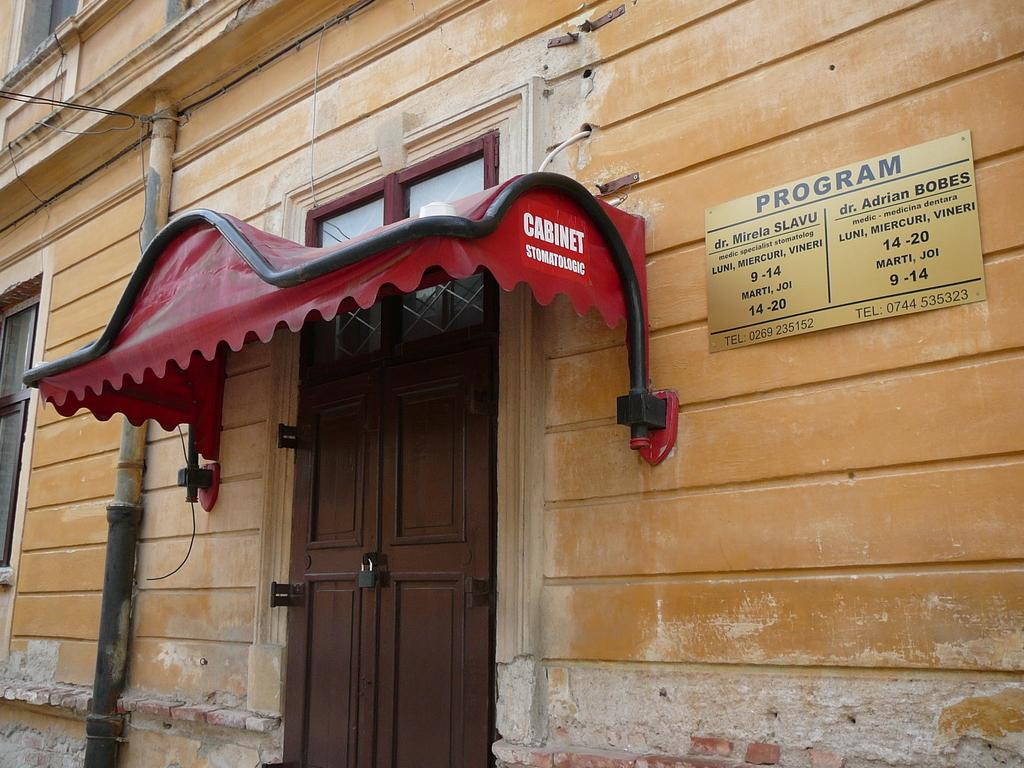What is present on the building in the image? There is a door on the building in the image. What feature is present on the door? There is a lock on the door in the image. What type of rifle can be seen leaning against the door in the image? There is no rifle present in the image; only the door and lock are visible. What time does the watch on the door indicate in the image? There is no watch present in the image; only the door and lock are visible. 